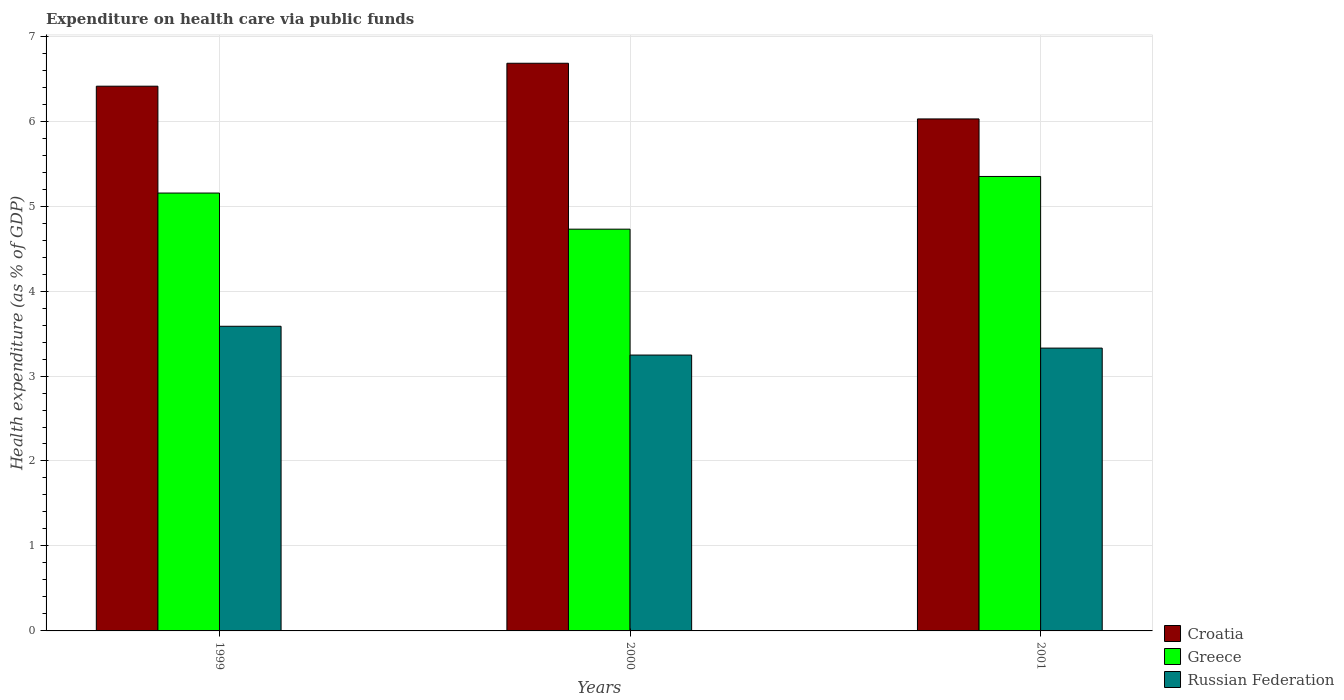How many different coloured bars are there?
Provide a short and direct response. 3. How many groups of bars are there?
Your answer should be compact. 3. How many bars are there on the 1st tick from the left?
Ensure brevity in your answer.  3. How many bars are there on the 2nd tick from the right?
Your answer should be compact. 3. What is the expenditure made on health care in Croatia in 1999?
Offer a terse response. 6.41. Across all years, what is the maximum expenditure made on health care in Russian Federation?
Your response must be concise. 3.59. Across all years, what is the minimum expenditure made on health care in Croatia?
Offer a very short reply. 6.03. In which year was the expenditure made on health care in Croatia minimum?
Offer a terse response. 2001. What is the total expenditure made on health care in Greece in the graph?
Ensure brevity in your answer.  15.23. What is the difference between the expenditure made on health care in Russian Federation in 1999 and that in 2000?
Provide a succinct answer. 0.34. What is the difference between the expenditure made on health care in Russian Federation in 2000 and the expenditure made on health care in Croatia in 1999?
Make the answer very short. -3.16. What is the average expenditure made on health care in Croatia per year?
Make the answer very short. 6.37. In the year 1999, what is the difference between the expenditure made on health care in Russian Federation and expenditure made on health care in Croatia?
Offer a very short reply. -2.83. What is the ratio of the expenditure made on health care in Croatia in 1999 to that in 2001?
Your answer should be compact. 1.06. Is the difference between the expenditure made on health care in Russian Federation in 2000 and 2001 greater than the difference between the expenditure made on health care in Croatia in 2000 and 2001?
Your response must be concise. No. What is the difference between the highest and the second highest expenditure made on health care in Russian Federation?
Provide a short and direct response. 0.26. What is the difference between the highest and the lowest expenditure made on health care in Croatia?
Give a very brief answer. 0.66. Is the sum of the expenditure made on health care in Russian Federation in 1999 and 2001 greater than the maximum expenditure made on health care in Croatia across all years?
Provide a short and direct response. Yes. What does the 1st bar from the left in 2001 represents?
Your answer should be very brief. Croatia. Is it the case that in every year, the sum of the expenditure made on health care in Greece and expenditure made on health care in Russian Federation is greater than the expenditure made on health care in Croatia?
Your response must be concise. Yes. How many bars are there?
Your answer should be very brief. 9. How many years are there in the graph?
Your answer should be compact. 3. Does the graph contain grids?
Your answer should be compact. Yes. How many legend labels are there?
Make the answer very short. 3. What is the title of the graph?
Your response must be concise. Expenditure on health care via public funds. What is the label or title of the Y-axis?
Offer a terse response. Health expenditure (as % of GDP). What is the Health expenditure (as % of GDP) of Croatia in 1999?
Your answer should be compact. 6.41. What is the Health expenditure (as % of GDP) in Greece in 1999?
Your answer should be very brief. 5.15. What is the Health expenditure (as % of GDP) in Russian Federation in 1999?
Give a very brief answer. 3.59. What is the Health expenditure (as % of GDP) of Croatia in 2000?
Ensure brevity in your answer.  6.68. What is the Health expenditure (as % of GDP) in Greece in 2000?
Offer a terse response. 4.73. What is the Health expenditure (as % of GDP) of Russian Federation in 2000?
Your answer should be compact. 3.25. What is the Health expenditure (as % of GDP) of Croatia in 2001?
Make the answer very short. 6.03. What is the Health expenditure (as % of GDP) in Greece in 2001?
Provide a short and direct response. 5.35. What is the Health expenditure (as % of GDP) in Russian Federation in 2001?
Your response must be concise. 3.33. Across all years, what is the maximum Health expenditure (as % of GDP) of Croatia?
Offer a terse response. 6.68. Across all years, what is the maximum Health expenditure (as % of GDP) in Greece?
Provide a succinct answer. 5.35. Across all years, what is the maximum Health expenditure (as % of GDP) in Russian Federation?
Ensure brevity in your answer.  3.59. Across all years, what is the minimum Health expenditure (as % of GDP) in Croatia?
Give a very brief answer. 6.03. Across all years, what is the minimum Health expenditure (as % of GDP) in Greece?
Make the answer very short. 4.73. Across all years, what is the minimum Health expenditure (as % of GDP) in Russian Federation?
Keep it short and to the point. 3.25. What is the total Health expenditure (as % of GDP) of Croatia in the graph?
Offer a very short reply. 19.12. What is the total Health expenditure (as % of GDP) of Greece in the graph?
Your response must be concise. 15.23. What is the total Health expenditure (as % of GDP) in Russian Federation in the graph?
Your response must be concise. 10.16. What is the difference between the Health expenditure (as % of GDP) of Croatia in 1999 and that in 2000?
Your response must be concise. -0.27. What is the difference between the Health expenditure (as % of GDP) in Greece in 1999 and that in 2000?
Ensure brevity in your answer.  0.42. What is the difference between the Health expenditure (as % of GDP) of Russian Federation in 1999 and that in 2000?
Your answer should be very brief. 0.34. What is the difference between the Health expenditure (as % of GDP) in Croatia in 1999 and that in 2001?
Offer a very short reply. 0.39. What is the difference between the Health expenditure (as % of GDP) of Greece in 1999 and that in 2001?
Your answer should be very brief. -0.2. What is the difference between the Health expenditure (as % of GDP) in Russian Federation in 1999 and that in 2001?
Give a very brief answer. 0.26. What is the difference between the Health expenditure (as % of GDP) in Croatia in 2000 and that in 2001?
Ensure brevity in your answer.  0.66. What is the difference between the Health expenditure (as % of GDP) in Greece in 2000 and that in 2001?
Your answer should be compact. -0.62. What is the difference between the Health expenditure (as % of GDP) in Russian Federation in 2000 and that in 2001?
Make the answer very short. -0.08. What is the difference between the Health expenditure (as % of GDP) of Croatia in 1999 and the Health expenditure (as % of GDP) of Greece in 2000?
Offer a very short reply. 1.68. What is the difference between the Health expenditure (as % of GDP) of Croatia in 1999 and the Health expenditure (as % of GDP) of Russian Federation in 2000?
Provide a short and direct response. 3.16. What is the difference between the Health expenditure (as % of GDP) of Greece in 1999 and the Health expenditure (as % of GDP) of Russian Federation in 2000?
Your answer should be very brief. 1.91. What is the difference between the Health expenditure (as % of GDP) of Croatia in 1999 and the Health expenditure (as % of GDP) of Greece in 2001?
Provide a succinct answer. 1.06. What is the difference between the Health expenditure (as % of GDP) of Croatia in 1999 and the Health expenditure (as % of GDP) of Russian Federation in 2001?
Your answer should be compact. 3.08. What is the difference between the Health expenditure (as % of GDP) of Greece in 1999 and the Health expenditure (as % of GDP) of Russian Federation in 2001?
Provide a succinct answer. 1.82. What is the difference between the Health expenditure (as % of GDP) of Croatia in 2000 and the Health expenditure (as % of GDP) of Greece in 2001?
Your answer should be very brief. 1.33. What is the difference between the Health expenditure (as % of GDP) in Croatia in 2000 and the Health expenditure (as % of GDP) in Russian Federation in 2001?
Your answer should be compact. 3.35. What is the difference between the Health expenditure (as % of GDP) of Greece in 2000 and the Health expenditure (as % of GDP) of Russian Federation in 2001?
Your answer should be very brief. 1.4. What is the average Health expenditure (as % of GDP) of Croatia per year?
Your response must be concise. 6.37. What is the average Health expenditure (as % of GDP) of Greece per year?
Give a very brief answer. 5.08. What is the average Health expenditure (as % of GDP) of Russian Federation per year?
Give a very brief answer. 3.39. In the year 1999, what is the difference between the Health expenditure (as % of GDP) of Croatia and Health expenditure (as % of GDP) of Greece?
Give a very brief answer. 1.26. In the year 1999, what is the difference between the Health expenditure (as % of GDP) of Croatia and Health expenditure (as % of GDP) of Russian Federation?
Ensure brevity in your answer.  2.83. In the year 1999, what is the difference between the Health expenditure (as % of GDP) in Greece and Health expenditure (as % of GDP) in Russian Federation?
Make the answer very short. 1.57. In the year 2000, what is the difference between the Health expenditure (as % of GDP) of Croatia and Health expenditure (as % of GDP) of Greece?
Your response must be concise. 1.95. In the year 2000, what is the difference between the Health expenditure (as % of GDP) in Croatia and Health expenditure (as % of GDP) in Russian Federation?
Make the answer very short. 3.43. In the year 2000, what is the difference between the Health expenditure (as % of GDP) of Greece and Health expenditure (as % of GDP) of Russian Federation?
Offer a terse response. 1.48. In the year 2001, what is the difference between the Health expenditure (as % of GDP) in Croatia and Health expenditure (as % of GDP) in Greece?
Ensure brevity in your answer.  0.68. In the year 2001, what is the difference between the Health expenditure (as % of GDP) in Croatia and Health expenditure (as % of GDP) in Russian Federation?
Give a very brief answer. 2.7. In the year 2001, what is the difference between the Health expenditure (as % of GDP) in Greece and Health expenditure (as % of GDP) in Russian Federation?
Your response must be concise. 2.02. What is the ratio of the Health expenditure (as % of GDP) in Croatia in 1999 to that in 2000?
Offer a very short reply. 0.96. What is the ratio of the Health expenditure (as % of GDP) in Greece in 1999 to that in 2000?
Offer a terse response. 1.09. What is the ratio of the Health expenditure (as % of GDP) in Russian Federation in 1999 to that in 2000?
Ensure brevity in your answer.  1.1. What is the ratio of the Health expenditure (as % of GDP) in Croatia in 1999 to that in 2001?
Your response must be concise. 1.06. What is the ratio of the Health expenditure (as % of GDP) in Greece in 1999 to that in 2001?
Give a very brief answer. 0.96. What is the ratio of the Health expenditure (as % of GDP) of Russian Federation in 1999 to that in 2001?
Offer a very short reply. 1.08. What is the ratio of the Health expenditure (as % of GDP) in Croatia in 2000 to that in 2001?
Your answer should be compact. 1.11. What is the ratio of the Health expenditure (as % of GDP) in Greece in 2000 to that in 2001?
Keep it short and to the point. 0.88. What is the ratio of the Health expenditure (as % of GDP) of Russian Federation in 2000 to that in 2001?
Provide a short and direct response. 0.98. What is the difference between the highest and the second highest Health expenditure (as % of GDP) of Croatia?
Ensure brevity in your answer.  0.27. What is the difference between the highest and the second highest Health expenditure (as % of GDP) of Greece?
Keep it short and to the point. 0.2. What is the difference between the highest and the second highest Health expenditure (as % of GDP) of Russian Federation?
Offer a very short reply. 0.26. What is the difference between the highest and the lowest Health expenditure (as % of GDP) in Croatia?
Your answer should be compact. 0.66. What is the difference between the highest and the lowest Health expenditure (as % of GDP) of Greece?
Your response must be concise. 0.62. What is the difference between the highest and the lowest Health expenditure (as % of GDP) in Russian Federation?
Your answer should be very brief. 0.34. 